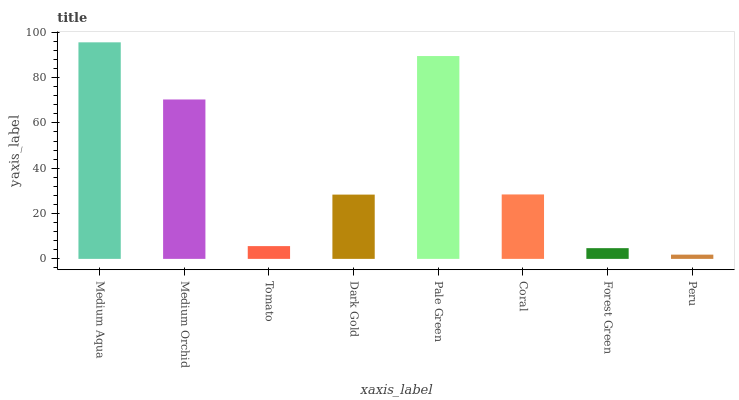Is Peru the minimum?
Answer yes or no. Yes. Is Medium Aqua the maximum?
Answer yes or no. Yes. Is Medium Orchid the minimum?
Answer yes or no. No. Is Medium Orchid the maximum?
Answer yes or no. No. Is Medium Aqua greater than Medium Orchid?
Answer yes or no. Yes. Is Medium Orchid less than Medium Aqua?
Answer yes or no. Yes. Is Medium Orchid greater than Medium Aqua?
Answer yes or no. No. Is Medium Aqua less than Medium Orchid?
Answer yes or no. No. Is Coral the high median?
Answer yes or no. Yes. Is Dark Gold the low median?
Answer yes or no. Yes. Is Tomato the high median?
Answer yes or no. No. Is Medium Aqua the low median?
Answer yes or no. No. 